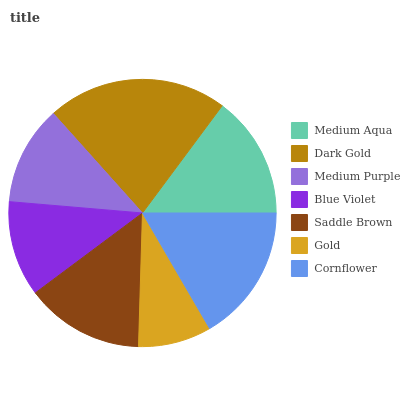Is Gold the minimum?
Answer yes or no. Yes. Is Dark Gold the maximum?
Answer yes or no. Yes. Is Medium Purple the minimum?
Answer yes or no. No. Is Medium Purple the maximum?
Answer yes or no. No. Is Dark Gold greater than Medium Purple?
Answer yes or no. Yes. Is Medium Purple less than Dark Gold?
Answer yes or no. Yes. Is Medium Purple greater than Dark Gold?
Answer yes or no. No. Is Dark Gold less than Medium Purple?
Answer yes or no. No. Is Saddle Brown the high median?
Answer yes or no. Yes. Is Saddle Brown the low median?
Answer yes or no. Yes. Is Blue Violet the high median?
Answer yes or no. No. Is Cornflower the low median?
Answer yes or no. No. 